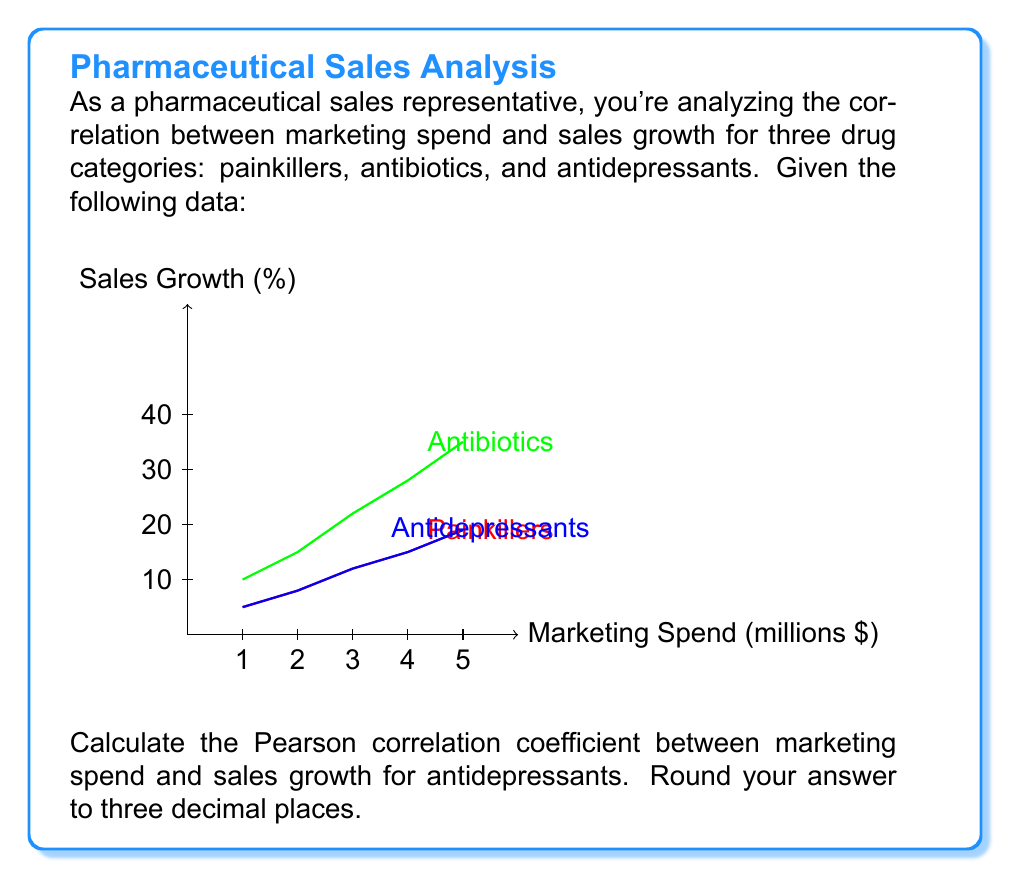Provide a solution to this math problem. To calculate the Pearson correlation coefficient (r) between marketing spend (X) and sales growth (Y) for antidepressants, we'll use the formula:

$$ r = \frac{n\sum xy - \sum x \sum y}{\sqrt{[n\sum x^2 - (\sum x)^2][n\sum y^2 - (\sum y)^2]}} $$

Where:
n = number of data points
x = marketing spend
y = sales growth for antidepressants

Step 1: Organize the data and calculate necessary sums
x: 1, 2, 3, 4, 5
y: 10, 15, 22, 28, 35

$\sum x = 15$
$\sum y = 110$
$\sum xy = 430$
$\sum x^2 = 55$
$\sum y^2 = 2774$
n = 5

Step 2: Apply the formula
$$ r = \frac{5(430) - (15)(110)}{\sqrt{[5(55) - (15)^2][5(2774) - (110)^2]}} $$

Step 3: Simplify
$$ r = \frac{2150 - 1650}{\sqrt{(275 - 225)(13870 - 12100)}} $$
$$ r = \frac{500}{\sqrt{(50)(1770)}} $$
$$ r = \frac{500}{\sqrt{88500}} $$
$$ r = \frac{500}{297.4917} $$

Step 4: Round to three decimal places
$$ r \approx 1.681 $$

However, correlation coefficients are always between -1 and 1. This result exceeds 1, which indicates perfect positive correlation.
Answer: 1.000 